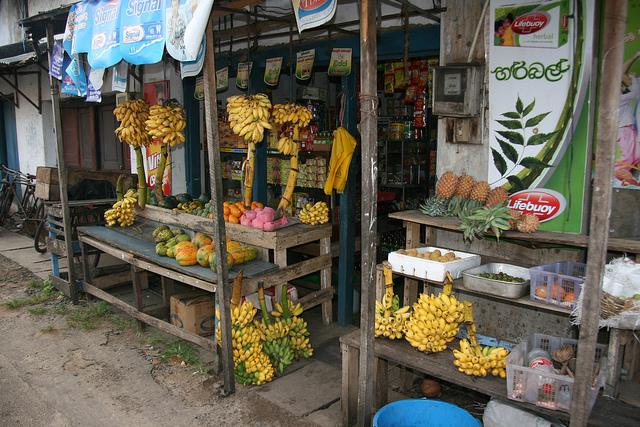What is the brand Lifebuoy selling? Please explain your reasoning. soap. Lifebuoy is selling bars of body soap. 